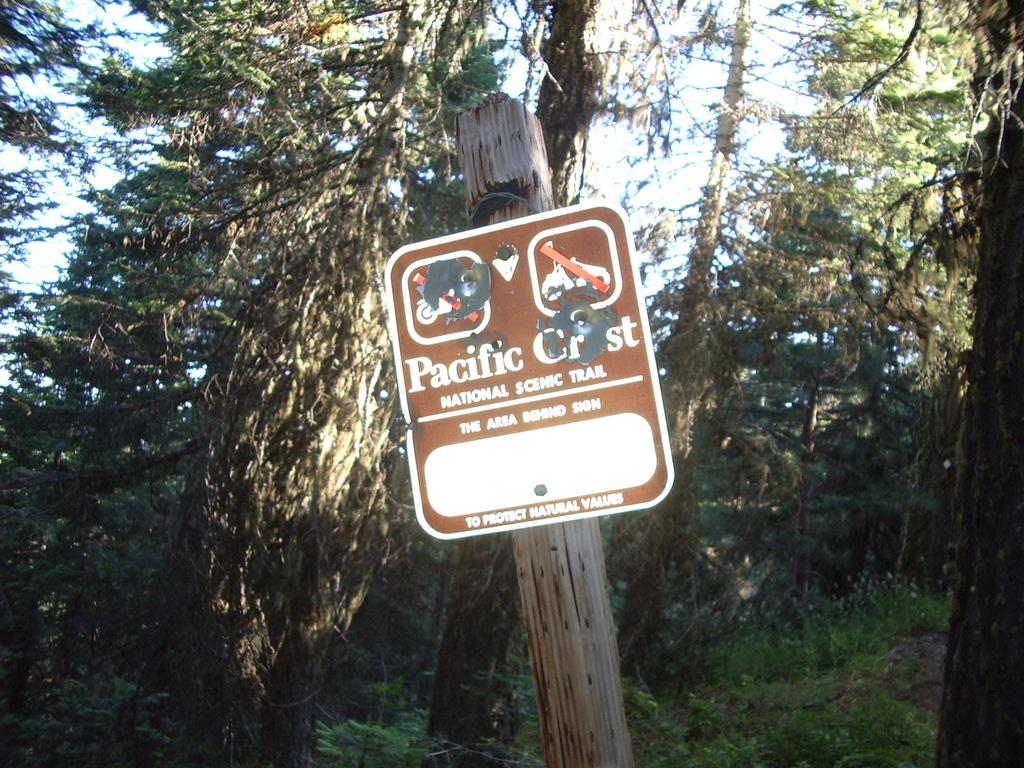What type of vegetation can be seen in the image? There are trees in the image. What object made of wood is present in the image? There is a wooden pole in the image. What is attached to the wooden pole? The wooden pole has a caution board on it. What type of pest can be seen crawling on the caution board in the image? There are no pests visible in the image, and no pests are mentioned in the provided facts. Can you tell me how many bags are hanging from the wooden pole in the image? There are no bags present in the image, and no bags are mentioned in the provided facts. 